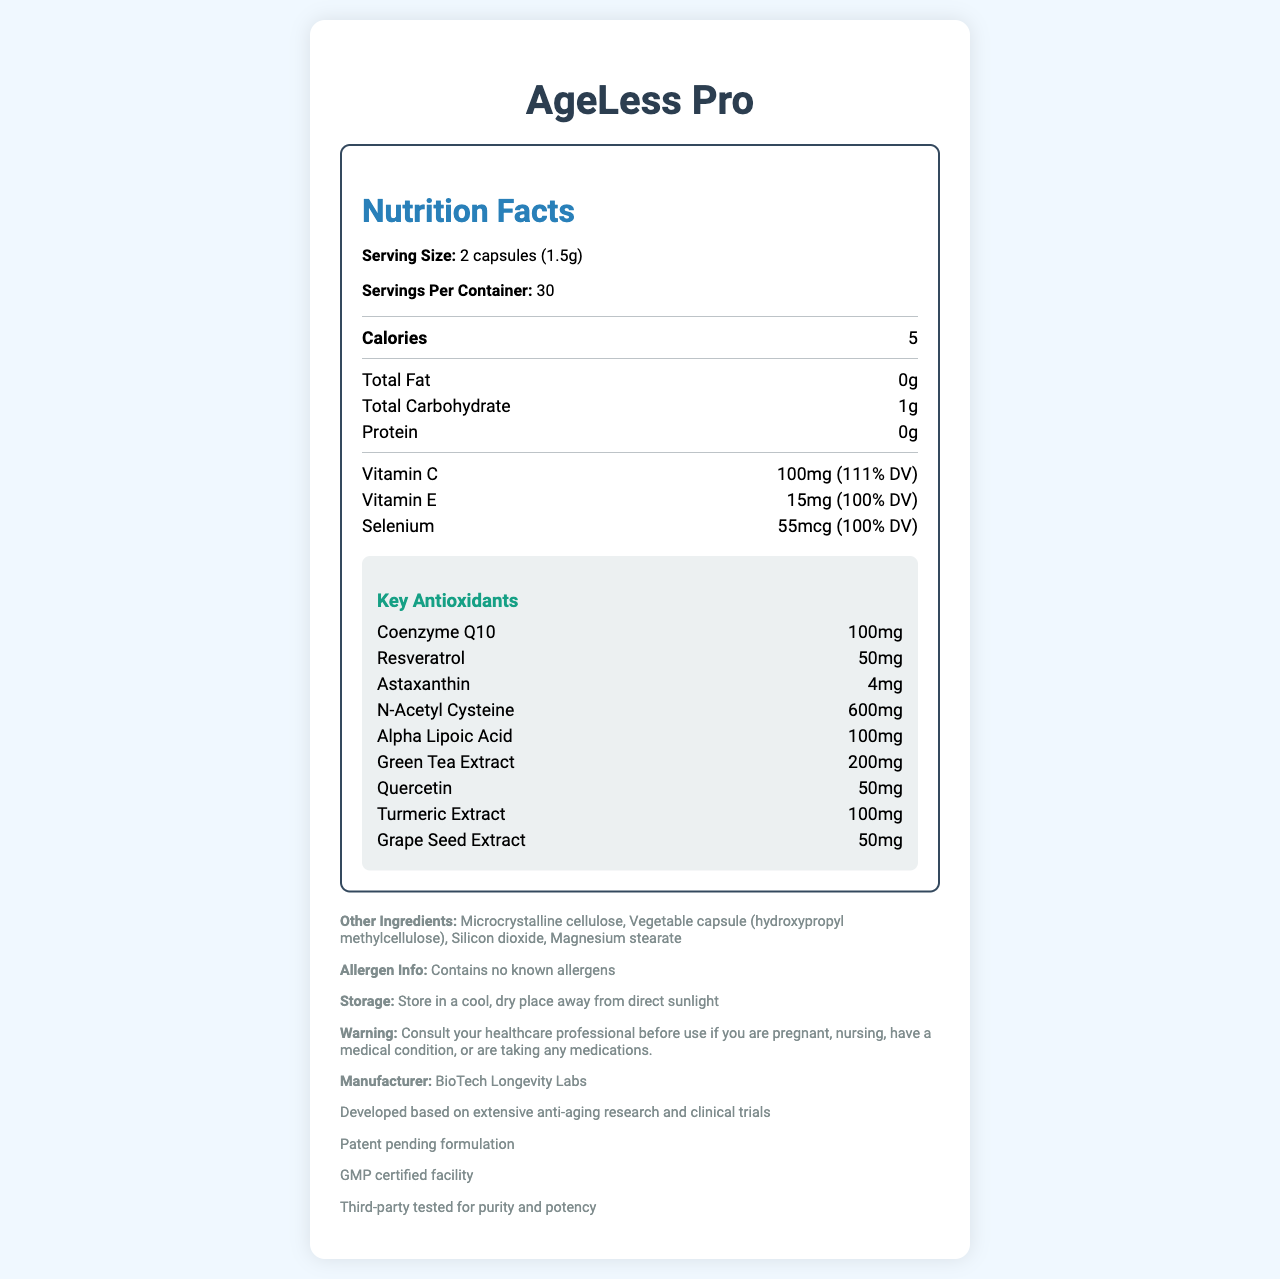what is the serving size of AgeLess Pro? The serving size is specified at the beginning of the Nutrition Facts section.
Answer: 2 capsules (1.5g) how many calories are in one serving of AgeLess Pro? The calorie content is provided in the Nutrition Facts section under the "Calories" label.
Answer: 5 how much Vitamin C is in one serving of AgeLess Pro? The amount of Vitamin C is listed in the Nutrition Facts section, indicating both the quantity and percentage of daily value (DV).
Answer: 100mg (111% DV) what is the quantity of N-Acetyl Cysteine in one serving? The Nutrition Facts section under the "Key Antioxidants" category lists the quantity of N-Acetyl Cysteine as 600mg.
Answer: 600mg who is the manufacturer of AgeLess Pro? The manufacturer's information is provided at the end of the document in the other information section.
Answer: BioTech Longevity Labs which ingredient is in the highest quantity per serving among key antioxidants? A. Coenzyme Q10 B. Resveratrol C. N-Acetyl Cysteine D. Alpha Lipoic Acid N-Acetyl Cysteine is listed as 600mg, which is higher than the quantities of other key antioxidants.
Answer: C. N-Acetyl Cysteine how many servings per container are there in AgeLess Pro? The number of servings per container is specified at the beginning of the Nutrition Facts section.
Answer: 30 which of the following is not an ingredient in AgeLess Pro? i. Vitamin E ii. Magnesium iii. Turmeric Extract iv. Beta-Carotene All listed ingredients except Beta-Carotene are mentioned in the document.
Answer: iv. Beta-Carotene is AgeLess Pro tested by a third party for purity and potency? The other information section mentions that AgeLess Pro is third-party tested for purity and potency.
Answer: Yes does AgeLess Pro contain any known allergens? The allergen information clearly states that the product contains no known allergens.
Answer: No what is the main idea of the document? The document is focused on presenting comprehensive nutritional and ingredient information about the anti-aging supplement, AgeLess Pro, including details regarding its antioxidants and other pertinent consumer information.
Answer: The document provides the Nutrition Facts label for AgeLess Pro, an anti-aging supplement, detailing its serving size, key nutritional components, antioxidants, other ingredients, allergen information, manufacturer, and quality assurance. what are the primary antioxidants included in AgeLess Pro? The document provides a detailed list of key antioxidants under a specific section titled "Key Antioxidants."
Answer: Coenzyme Q10, Resveratrol, Astaxanthin, N-Acetyl Cysteine, Alpha Lipoic Acid, Green Tea Extract, Quercetin, Turmeric Extract, Grape Seed Extract what is the percentage of daily value for Selenium in one serving? The Nutrition Facts section mentions Selenium as having 100% DV in one serving.
Answer: 100% DV is the formulation of AgeLess Pro patented? The other information section states that the formulation of AgeLess Pro is patent pending.
Answer: Patent pending how should AgeLess Pro be stored? The storage instructions are provided in the other information section.
Answer: Store in a cool, dry place away from direct sunlight can I take AgeLess Pro if I'm pregnant or nursing without consulting a healthcare professional? The warning section advises consulting a healthcare professional before use if pregnant, nursing, or having a medical condition.
Answer: No what is the percentage of daily value for Vitamin E in one serving? The Nutrition Facts section lists Vitamin E as having 100% DV in one serving.
Answer: 100% DV how much Green Tea Extract is there in one serving of AgeLess Pro? The amount of Green Tea Extract is specified in the Key Antioxidants section.
Answer: 200mg how does the document ensure the quality of AgeLess Pro? The other information section highlights quality assurance measures, including production in a GMP certified facility and third-party testing for purity and potency.
Answer: GMP certified facility, third-party tested is there any information about the manufacturing date of AgeLess Pro? The provided document does not include any details regarding the manufacturing date.
Answer: Not enough information 